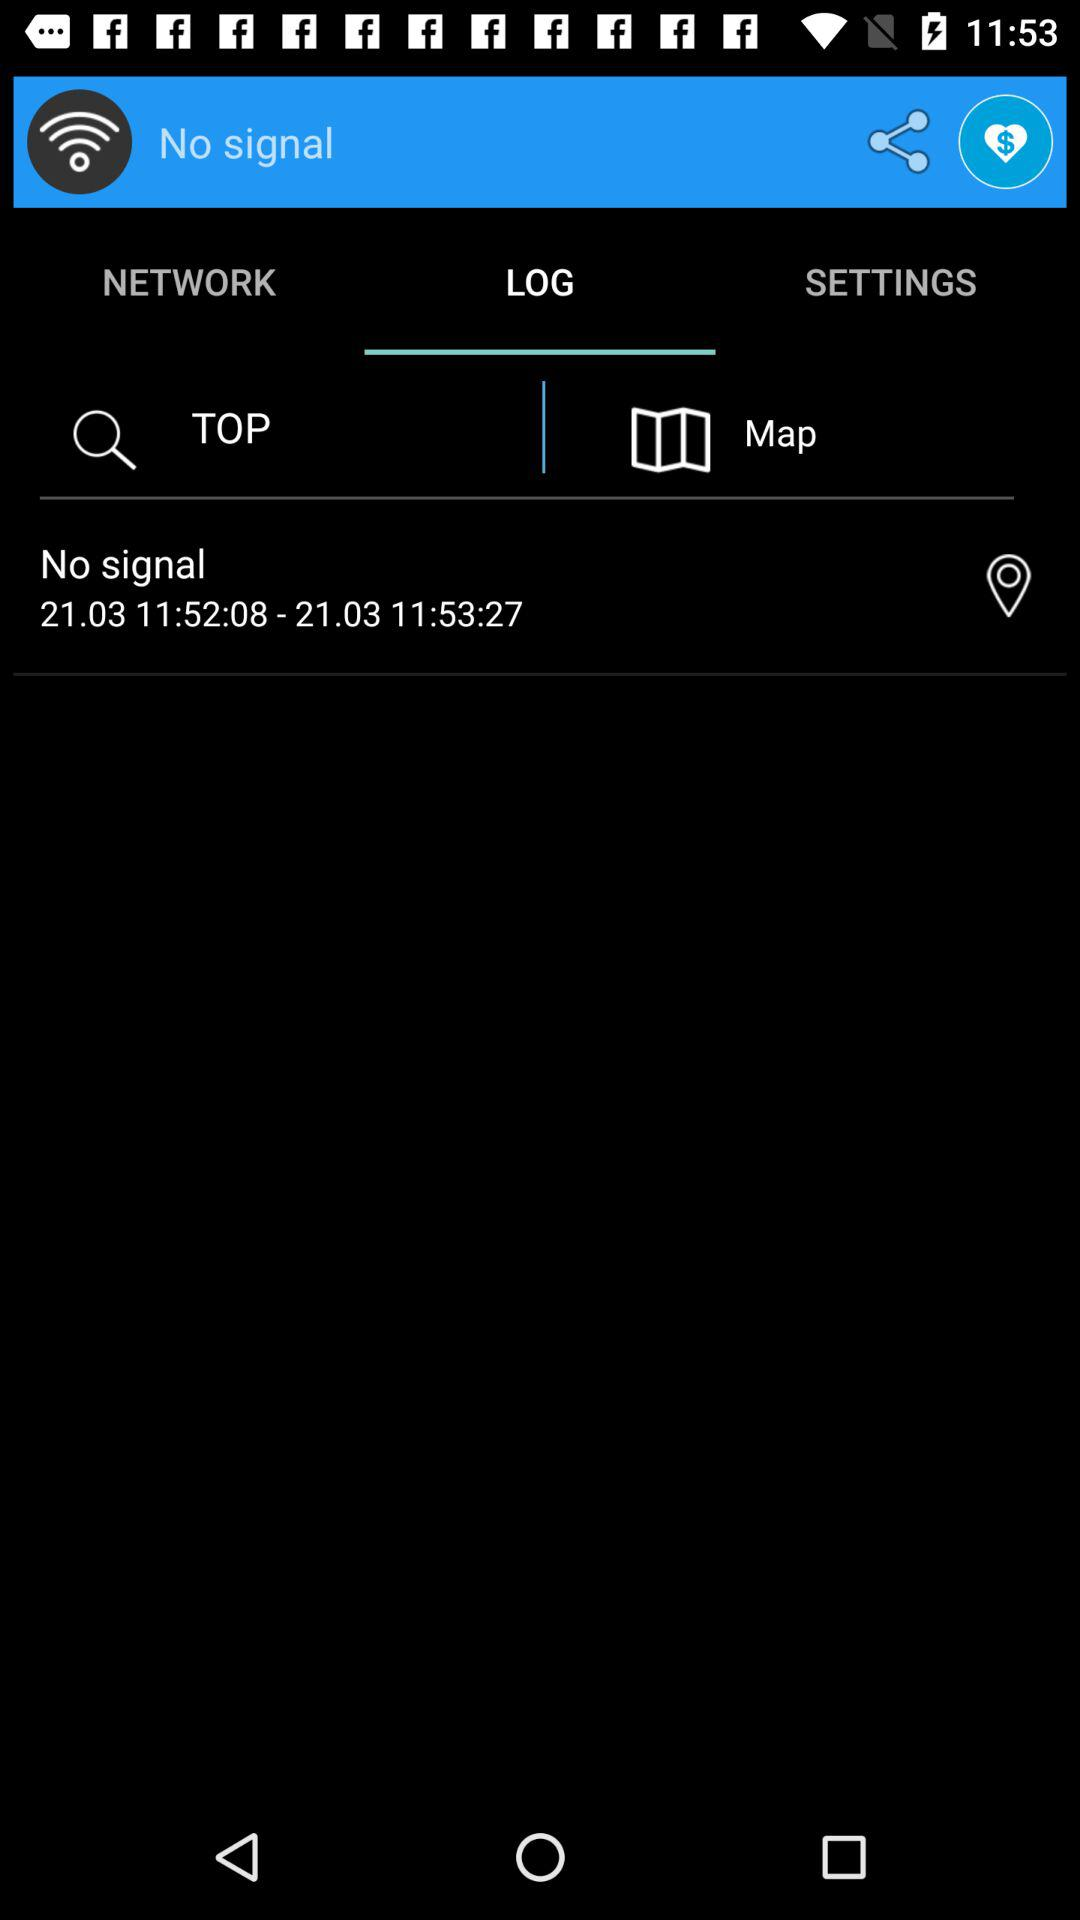Through which applications can this be shared?
When the provided information is insufficient, respond with <no answer>. <no answer> 